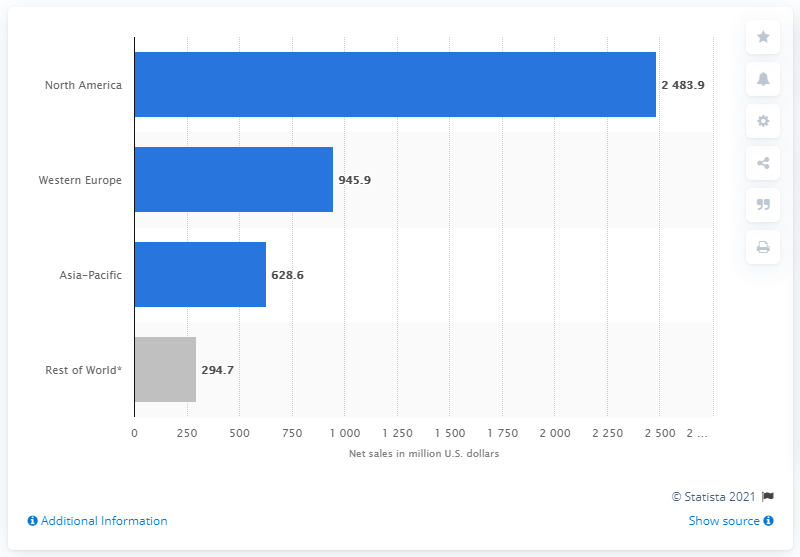Mention a couple of crucial points in this snapshot. The regions of Western Europe and Asia-Pacific, when combined, consist of a total of 1574.5. In 2020, a total of 628.6 million dollars of sales were generated in the Asia-Pacific region. The region that is colored grey is the "Rest of World". 